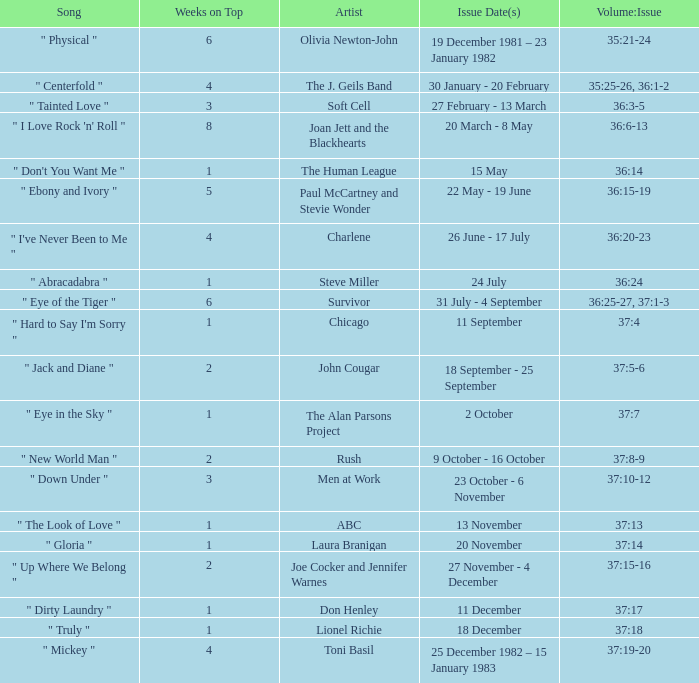Which "weeks on top" have an issue date(s) corresponding to november 20th? 1.0. Would you mind parsing the complete table? {'header': ['Song', 'Weeks on Top', 'Artist', 'Issue Date(s)', 'Volume:Issue'], 'rows': [['" Physical "', '6', 'Olivia Newton-John', '19 December 1981 – 23 January 1982', '35:21-24'], ['" Centerfold "', '4', 'The J. Geils Band', '30 January - 20 February', '35:25-26, 36:1-2'], ['" Tainted Love "', '3', 'Soft Cell', '27 February - 13 March', '36:3-5'], ['" I Love Rock \'n\' Roll "', '8', 'Joan Jett and the Blackhearts', '20 March - 8 May', '36:6-13'], ['" Don\'t You Want Me "', '1', 'The Human League', '15 May', '36:14'], ['" Ebony and Ivory "', '5', 'Paul McCartney and Stevie Wonder', '22 May - 19 June', '36:15-19'], ['" I\'ve Never Been to Me "', '4', 'Charlene', '26 June - 17 July', '36:20-23'], ['" Abracadabra "', '1', 'Steve Miller', '24 July', '36:24'], ['" Eye of the Tiger "', '6', 'Survivor', '31 July - 4 September', '36:25-27, 37:1-3'], ['" Hard to Say I\'m Sorry "', '1', 'Chicago', '11 September', '37:4'], ['" Jack and Diane "', '2', 'John Cougar', '18 September - 25 September', '37:5-6'], ['" Eye in the Sky "', '1', 'The Alan Parsons Project', '2 October', '37:7'], ['" New World Man "', '2', 'Rush', '9 October - 16 October', '37:8-9'], ['" Down Under "', '3', 'Men at Work', '23 October - 6 November', '37:10-12'], ['" The Look of Love "', '1', 'ABC', '13 November', '37:13'], ['" Gloria "', '1', 'Laura Branigan', '20 November', '37:14'], ['" Up Where We Belong "', '2', 'Joe Cocker and Jennifer Warnes', '27 November - 4 December', '37:15-16'], ['" Dirty Laundry "', '1', 'Don Henley', '11 December', '37:17'], ['" Truly "', '1', 'Lionel Richie', '18 December', '37:18'], ['" Mickey "', '4', 'Toni Basil', '25 December 1982 – 15 January 1983', '37:19-20']]} 